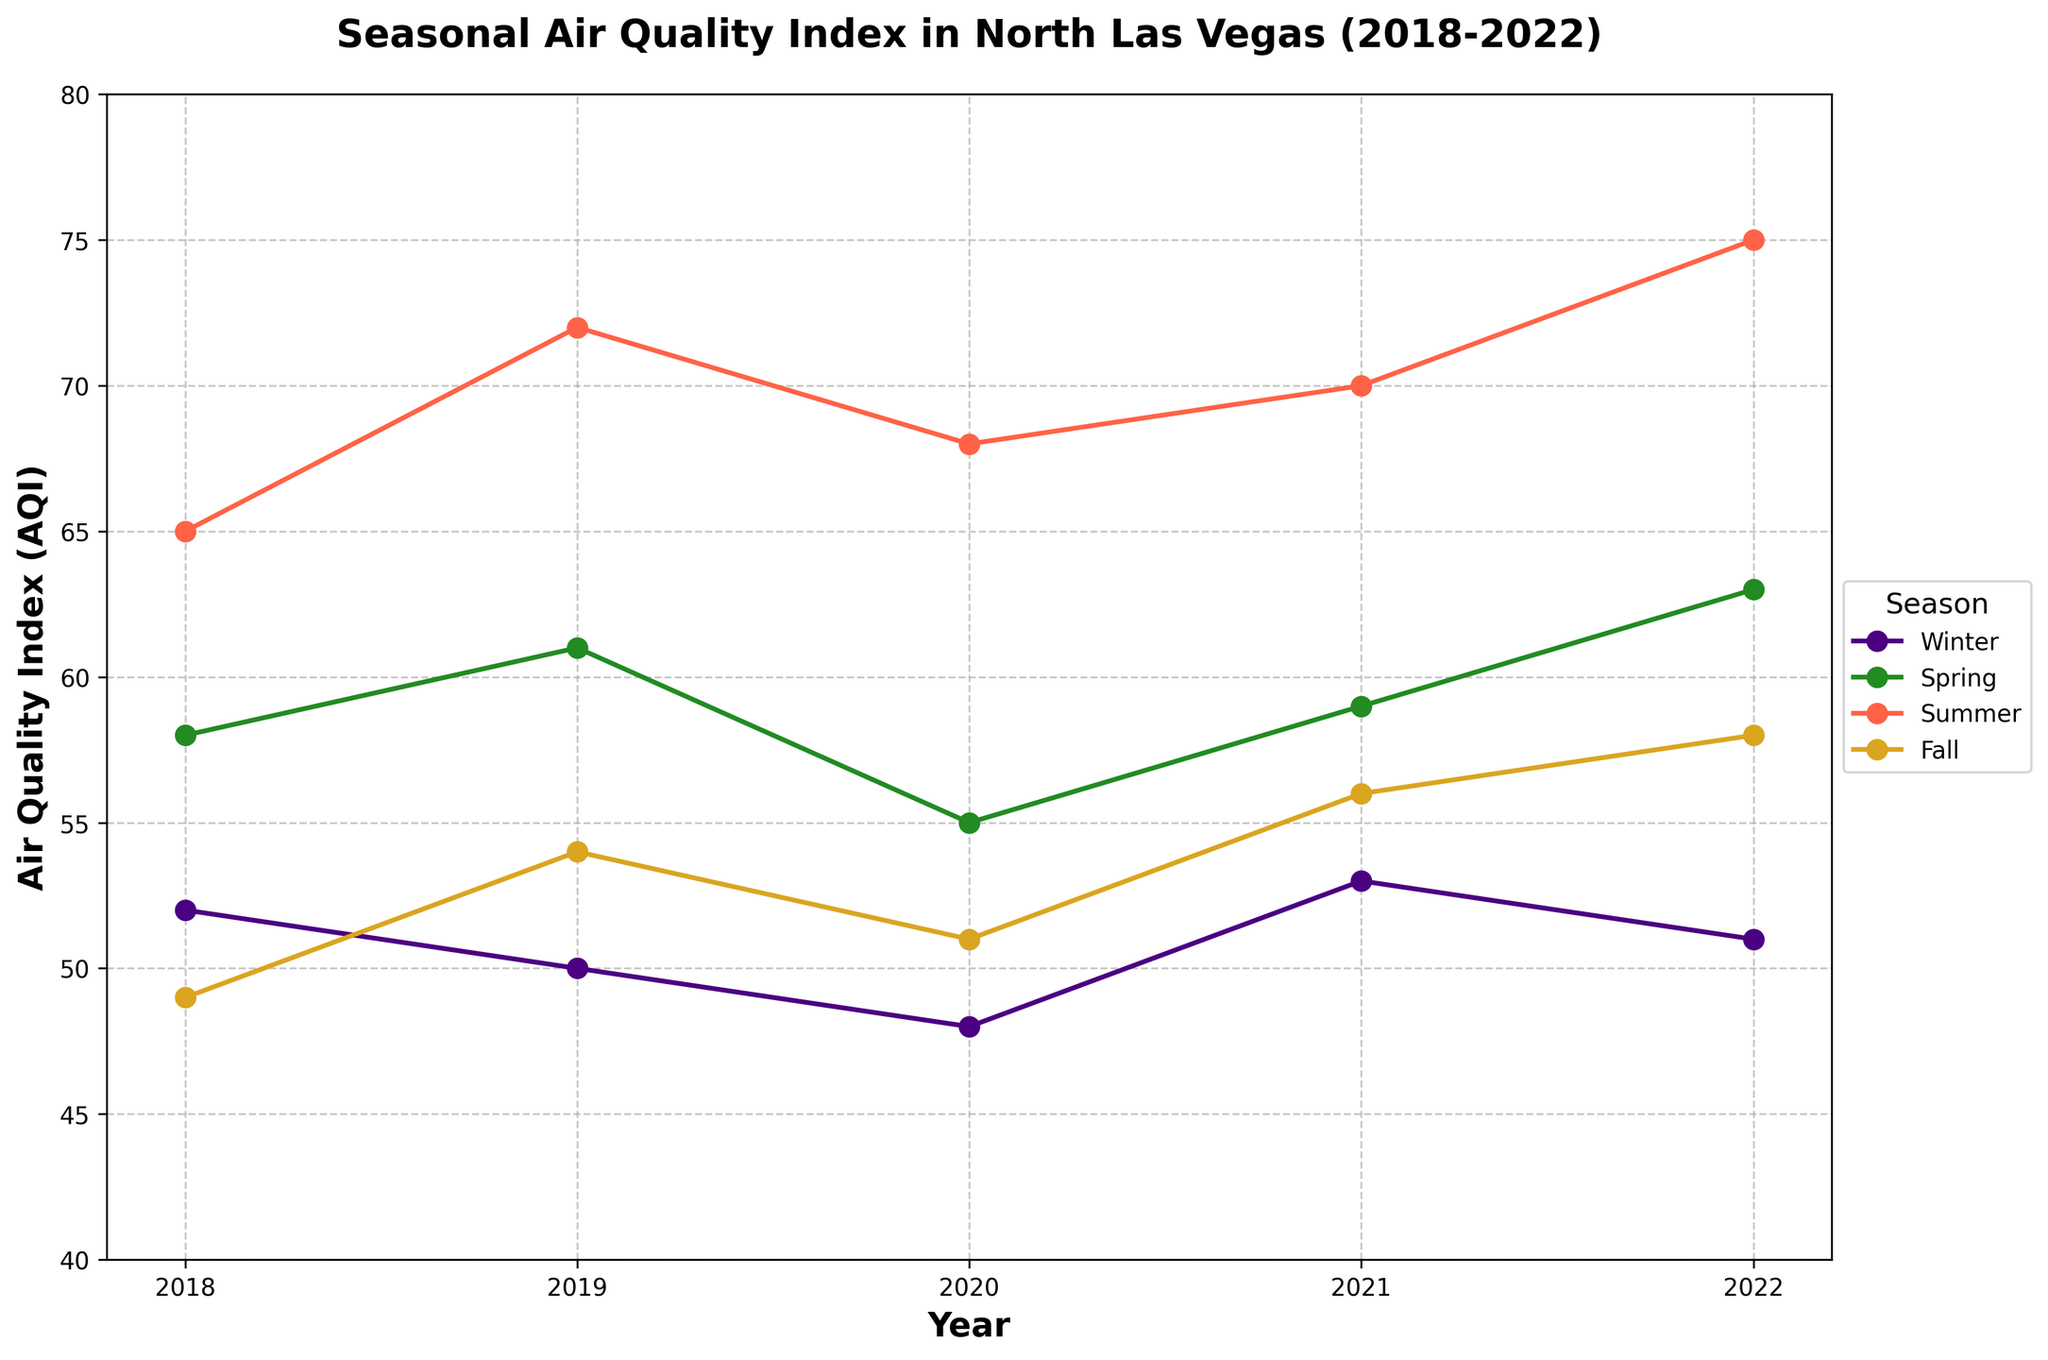Which season had the highest AQI in 2019? To find the highest AQI in 2019, we look at the AQI values across all seasons for that year. Winter had an AQI of 50, Spring was 61, Summer was 72, and Fall was 54. Summer has the highest AQI value.
Answer: Summer How did the AQI in Winter 2021 compare to Winter 2018? To compare the AQI in Winter 2021 to Winter 2018, note that Winter 2021 had an AQI of 53 and Winter 2018 had an AQI of 52. 53 is greater than 52.
Answer: It increased What is the average AQI for Summers from 2018 to 2022? First, sum the AQI values for Summers from 2018 to 2022: 65 + 72 + 68 + 70 + 75 = 350. Then, divide by the number of years, which is 5. Average AQI = 350 / 5.
Answer: 70 Which season showed consistent improvement in AQI from 2018 to 2022? Examine the AQI values for each season from 2018 to 2022. Winter (52, 50, 48, 53, 51) and Fall (49, 54, 51, 56, 58) had some fluctuations. Spring (58, 61, 55, 59, 63) and Summer (65, 72, 68, 70, 75) had fluctuations. No season showed consistent improvement.
Answer: None In which year was the overall seasonal variation in AQI the largest? Variations can be calculated as the difference between the highest and lowest AQI within each year. Calculate for each year:
2018: 65 - 49 = 16, 2019: 72 - 50 = 22, 2020: 68 - 48 = 20, 2021: 70 - 53 = 17, 2022: 75 - 51 = 24. The largest variation is 24 in 2022.
Answer: 2022 Identify the trend for Spring AQI levels over the five years? Observe the AQI values for Spring from 2018 to 2022: 58, 61, 55, 59, 63. The values show an overall increasing trend from 2018 to 2022, with a dip in 2020.
Answer: Increasing Which season had the lowest overall AQI level from 2018 to 2022? Calculate the average AQI for each season over the five years: Winter [(52+50+48+53+51)/5=50.8], Spring [(58+61+55+59+63)/5=59.2], Summer [(65+72+68+70+75)/5=70], Fall [(49+54+51+56+58)/5=53.6]. Winter has the lowest average AQI.
Answer: Winter During which season did the AQI peak in 2020? Look at the AQI values for each season in 2020: Winter (48), Spring (55), Summer (68), Fall (51). Summer had the highest AQI value.
Answer: Summer 